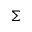<formula> <loc_0><loc_0><loc_500><loc_500>\Sigma</formula> 